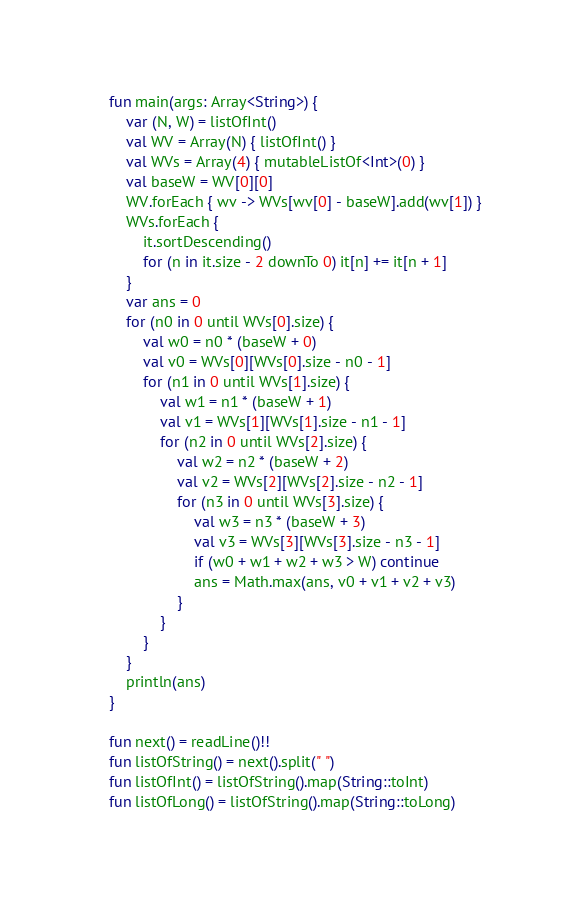Convert code to text. <code><loc_0><loc_0><loc_500><loc_500><_Kotlin_>fun main(args: Array<String>) {
    var (N, W) = listOfInt()
    val WV = Array(N) { listOfInt() }
    val WVs = Array(4) { mutableListOf<Int>(0) }
    val baseW = WV[0][0]
    WV.forEach { wv -> WVs[wv[0] - baseW].add(wv[1]) }
    WVs.forEach {
        it.sortDescending()
        for (n in it.size - 2 downTo 0) it[n] += it[n + 1]
    }
    var ans = 0
    for (n0 in 0 until WVs[0].size) {
        val w0 = n0 * (baseW + 0)
        val v0 = WVs[0][WVs[0].size - n0 - 1]
        for (n1 in 0 until WVs[1].size) {
            val w1 = n1 * (baseW + 1)
            val v1 = WVs[1][WVs[1].size - n1 - 1]
            for (n2 in 0 until WVs[2].size) {
                val w2 = n2 * (baseW + 2)
                val v2 = WVs[2][WVs[2].size - n2 - 1]
                for (n3 in 0 until WVs[3].size) {
                    val w3 = n3 * (baseW + 3)
                    val v3 = WVs[3][WVs[3].size - n3 - 1]
                    if (w0 + w1 + w2 + w3 > W) continue
                    ans = Math.max(ans, v0 + v1 + v2 + v3)
                }
            }
        }
    }
    println(ans)
}

fun next() = readLine()!!
fun listOfString() = next().split(" ")
fun listOfInt() = listOfString().map(String::toInt)
fun listOfLong() = listOfString().map(String::toLong)
</code> 